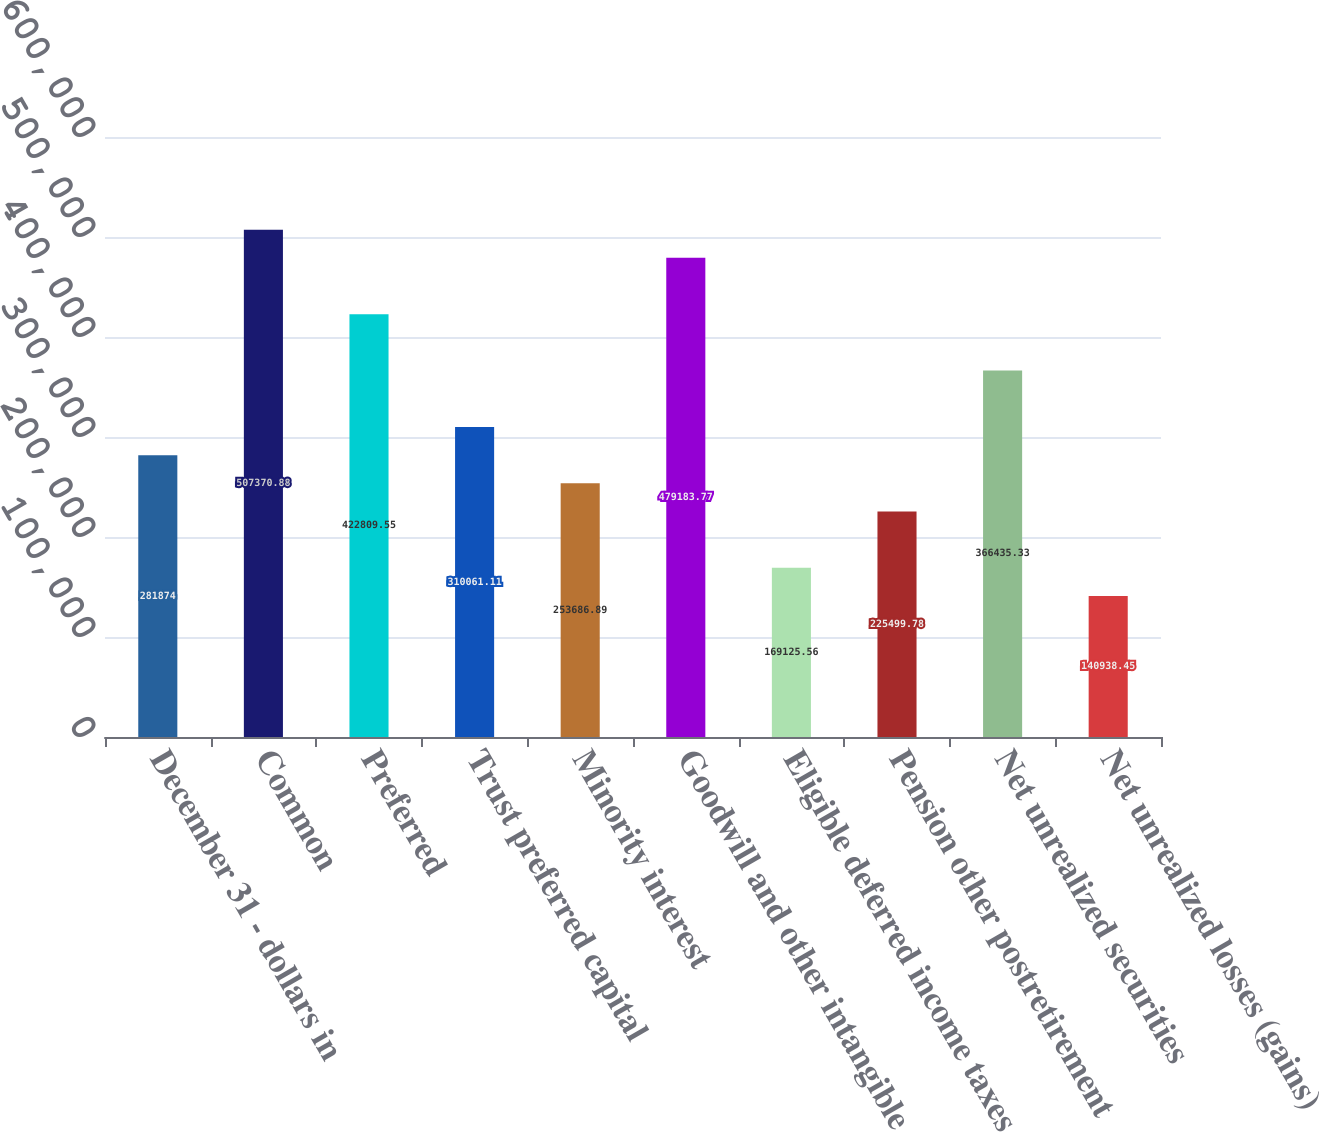Convert chart to OTSL. <chart><loc_0><loc_0><loc_500><loc_500><bar_chart><fcel>December 31 - dollars in<fcel>Common<fcel>Preferred<fcel>Trust preferred capital<fcel>Minority interest<fcel>Goodwill and other intangible<fcel>Eligible deferred income taxes<fcel>Pension other postretirement<fcel>Net unrealized securities<fcel>Net unrealized losses (gains)<nl><fcel>281874<fcel>507371<fcel>422810<fcel>310061<fcel>253687<fcel>479184<fcel>169126<fcel>225500<fcel>366435<fcel>140938<nl></chart> 